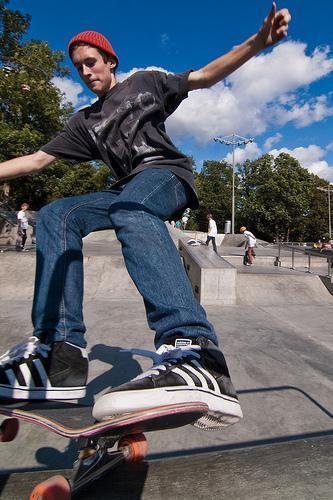How many stripes does the man have on each sneaker?
Give a very brief answer. 3. How many skaters in the picture have white t shirts on?
Give a very brief answer. 3. 